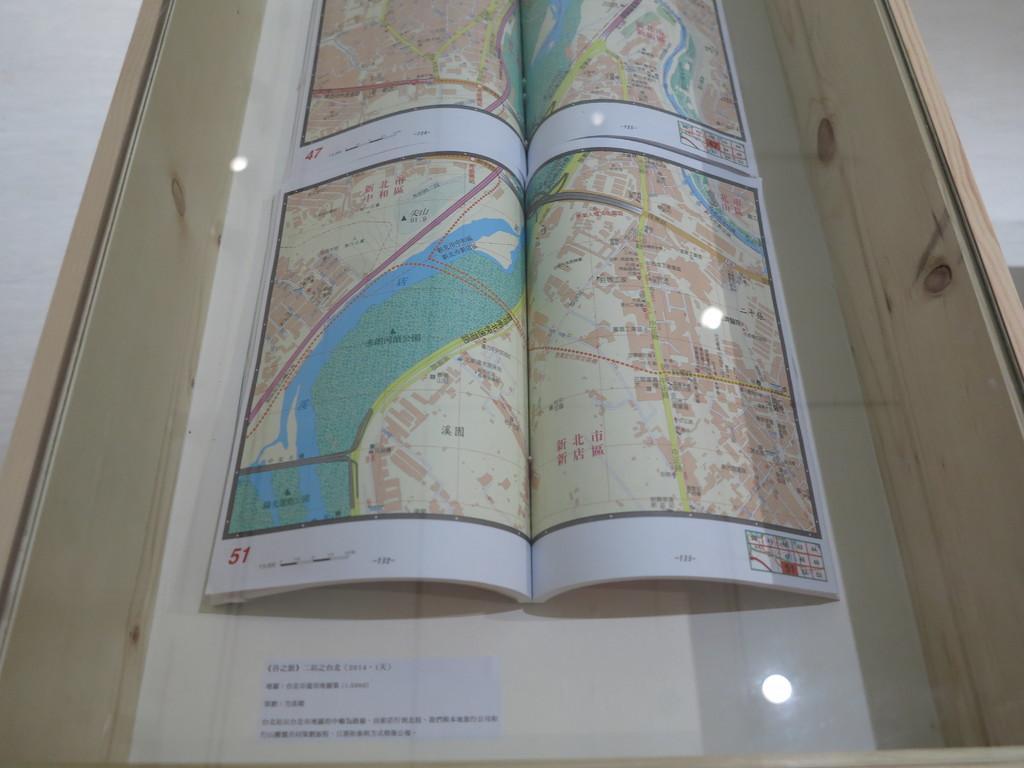In one or two sentences, can you explain what this image depicts? In this picture I see a wooden box with glass on the top and from the glass I see few maps in the box and text at the bottom of the picture. 